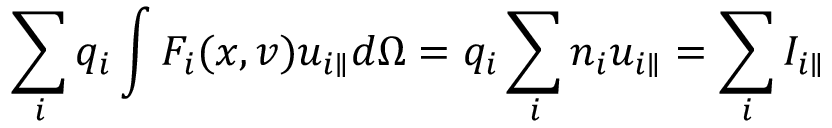Convert formula to latex. <formula><loc_0><loc_0><loc_500><loc_500>\sum _ { i } q _ { i } \int F _ { i } ( x , v ) u _ { i \| } d \Omega = q _ { i } \sum _ { i } n _ { i } u _ { i \| } = \sum _ { i } I _ { i \| }</formula> 